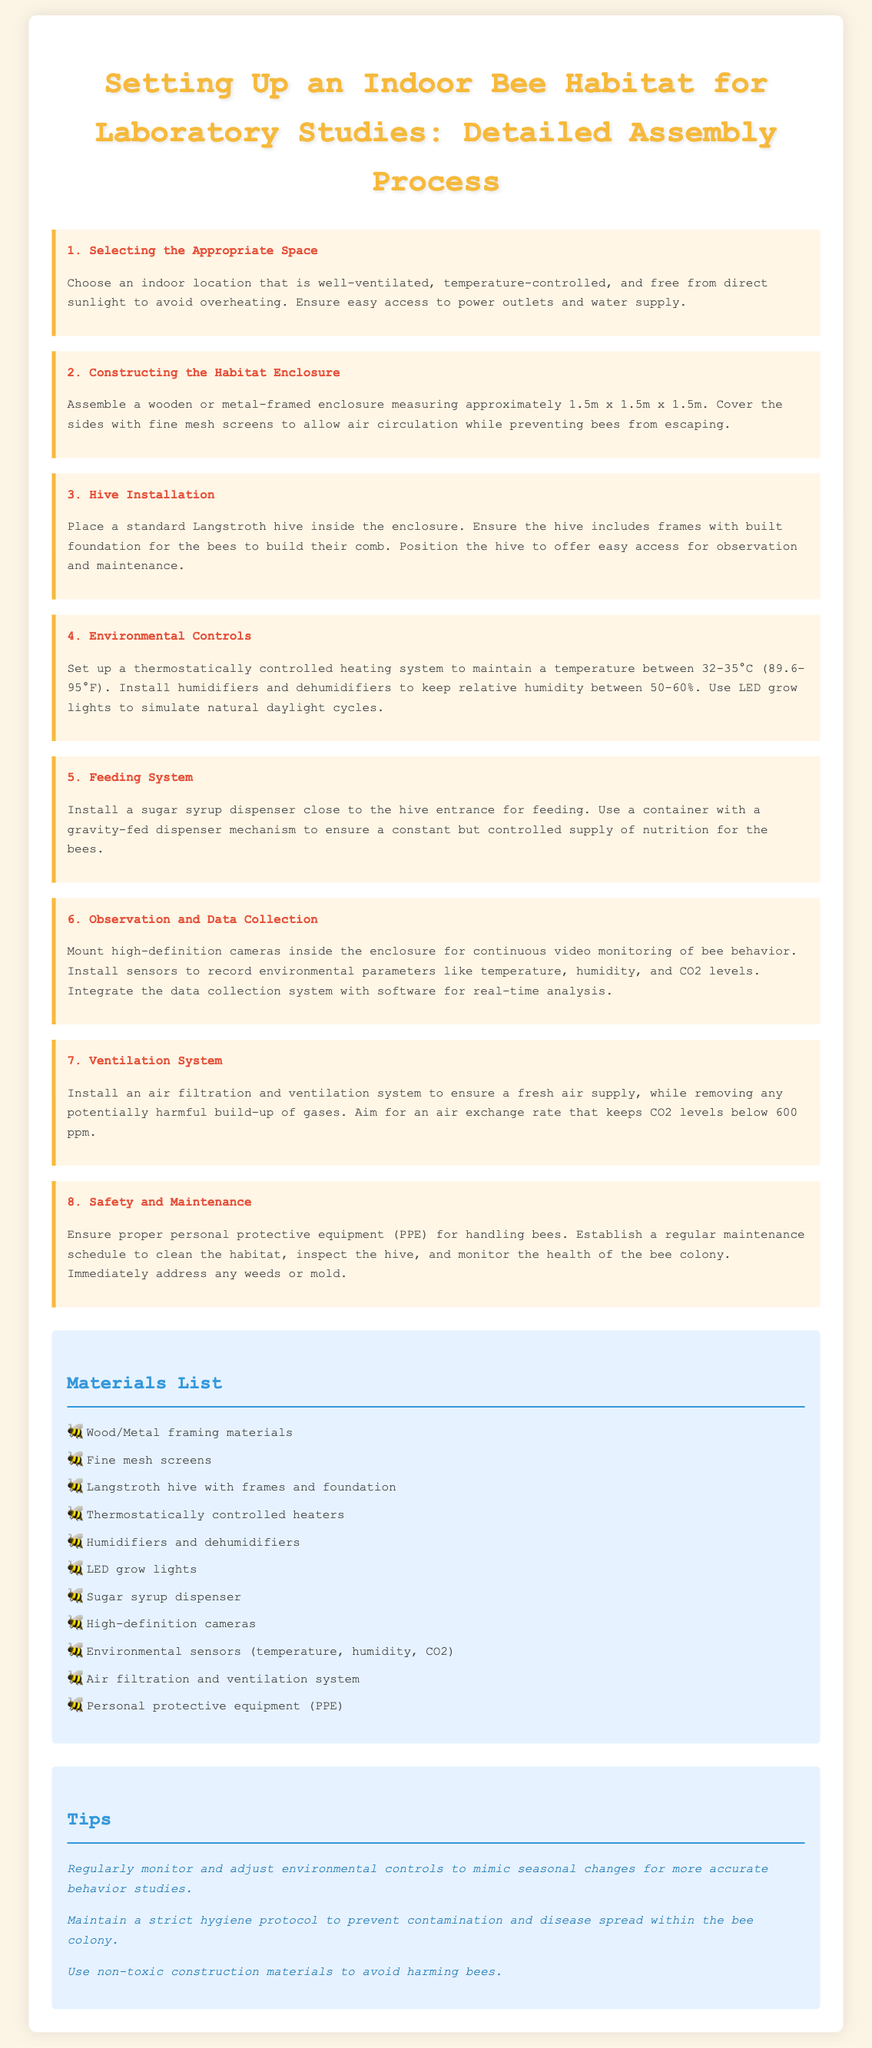What is the size of the habitat enclosure? The habitat enclosure measures approximately 1.5m x 1.5m x 1.5m as stated in the instructions.
Answer: 1.5m x 1.5m x 1.5m What temperature should be maintained in the habitat? The document specifies that the temperature should be maintained between 32-35°C (89.6-95°F).
Answer: 32-35°C (89.6-95°F) Which type of hive is recommended for installation? The instructions recommend installing a standard Langstroth hive within the enclosure.
Answer: Langstroth hive What is the purpose of the sugar syrup dispenser? The sugar syrup dispenser is used for feeding the bees, ensuring a controlled supply of nutrition.
Answer: Feeding How should the habitat enclosure be ventilated? An air filtration and ventilation system should be installed to ensure a fresh air supply.
Answer: Air filtration and ventilation system Why is it important to maintain hygiene in the habitat? Maintaining a strict hygiene protocol is essential to prevent contamination and disease spread within the bee colony.
Answer: Prevent contamination What is one of the environmental parameters monitored in the habitat? The document outlines that sensors should record temperature, humidity, and CO2 levels.
Answer: Temperature What should be used for personal protection when handling bees? The instructions emphasize the need for personal protective equipment (PPE) while handling bees.
Answer: Personal protective equipment (PPE) 